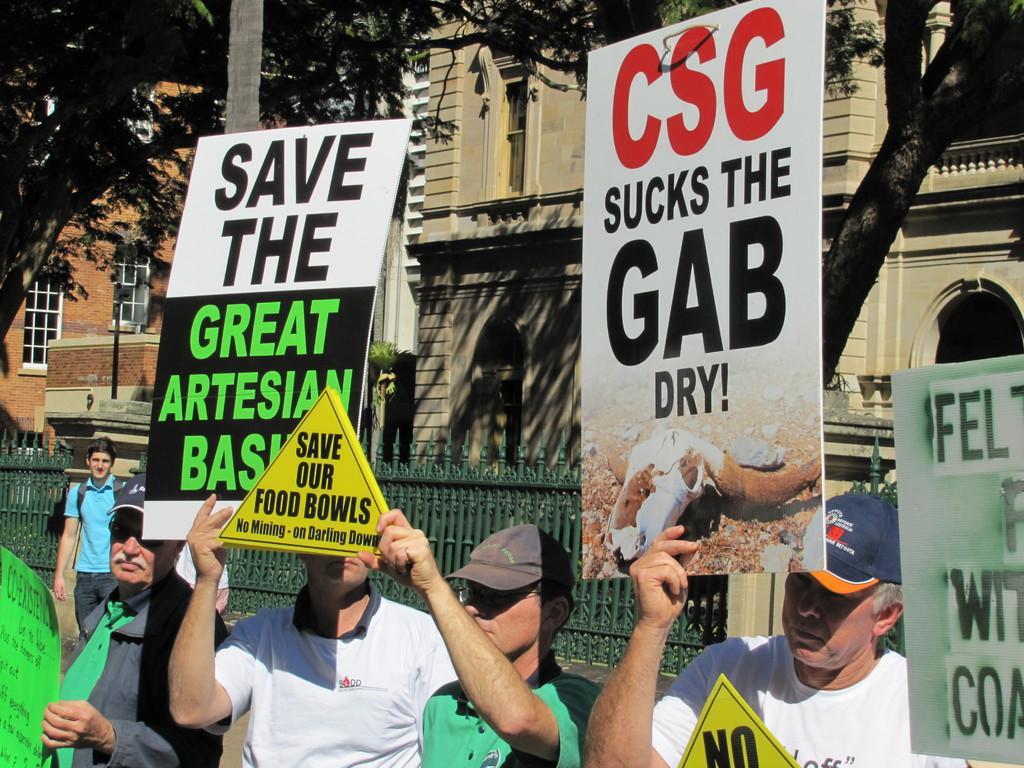How would you summarize this image in a sentence or two? In this image there are people holding the placards. Behind them there is a metal fence. In the background of the image there are buildings, trees. 